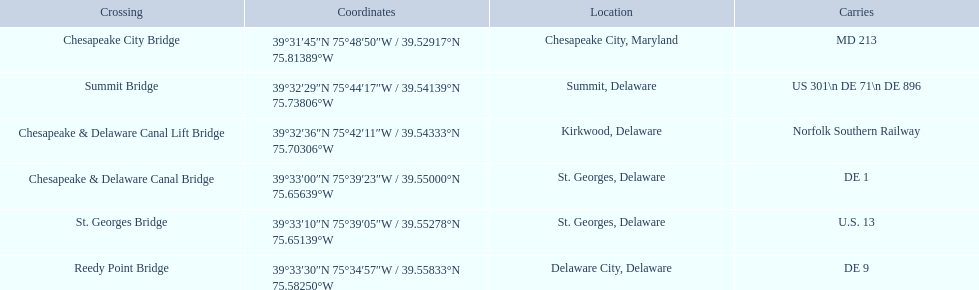Which bridges are in delaware? Summit Bridge, Chesapeake & Delaware Canal Lift Bridge, Chesapeake & Delaware Canal Bridge, St. Georges Bridge, Reedy Point Bridge. Which delaware bridge carries de 9? Reedy Point Bridge. 